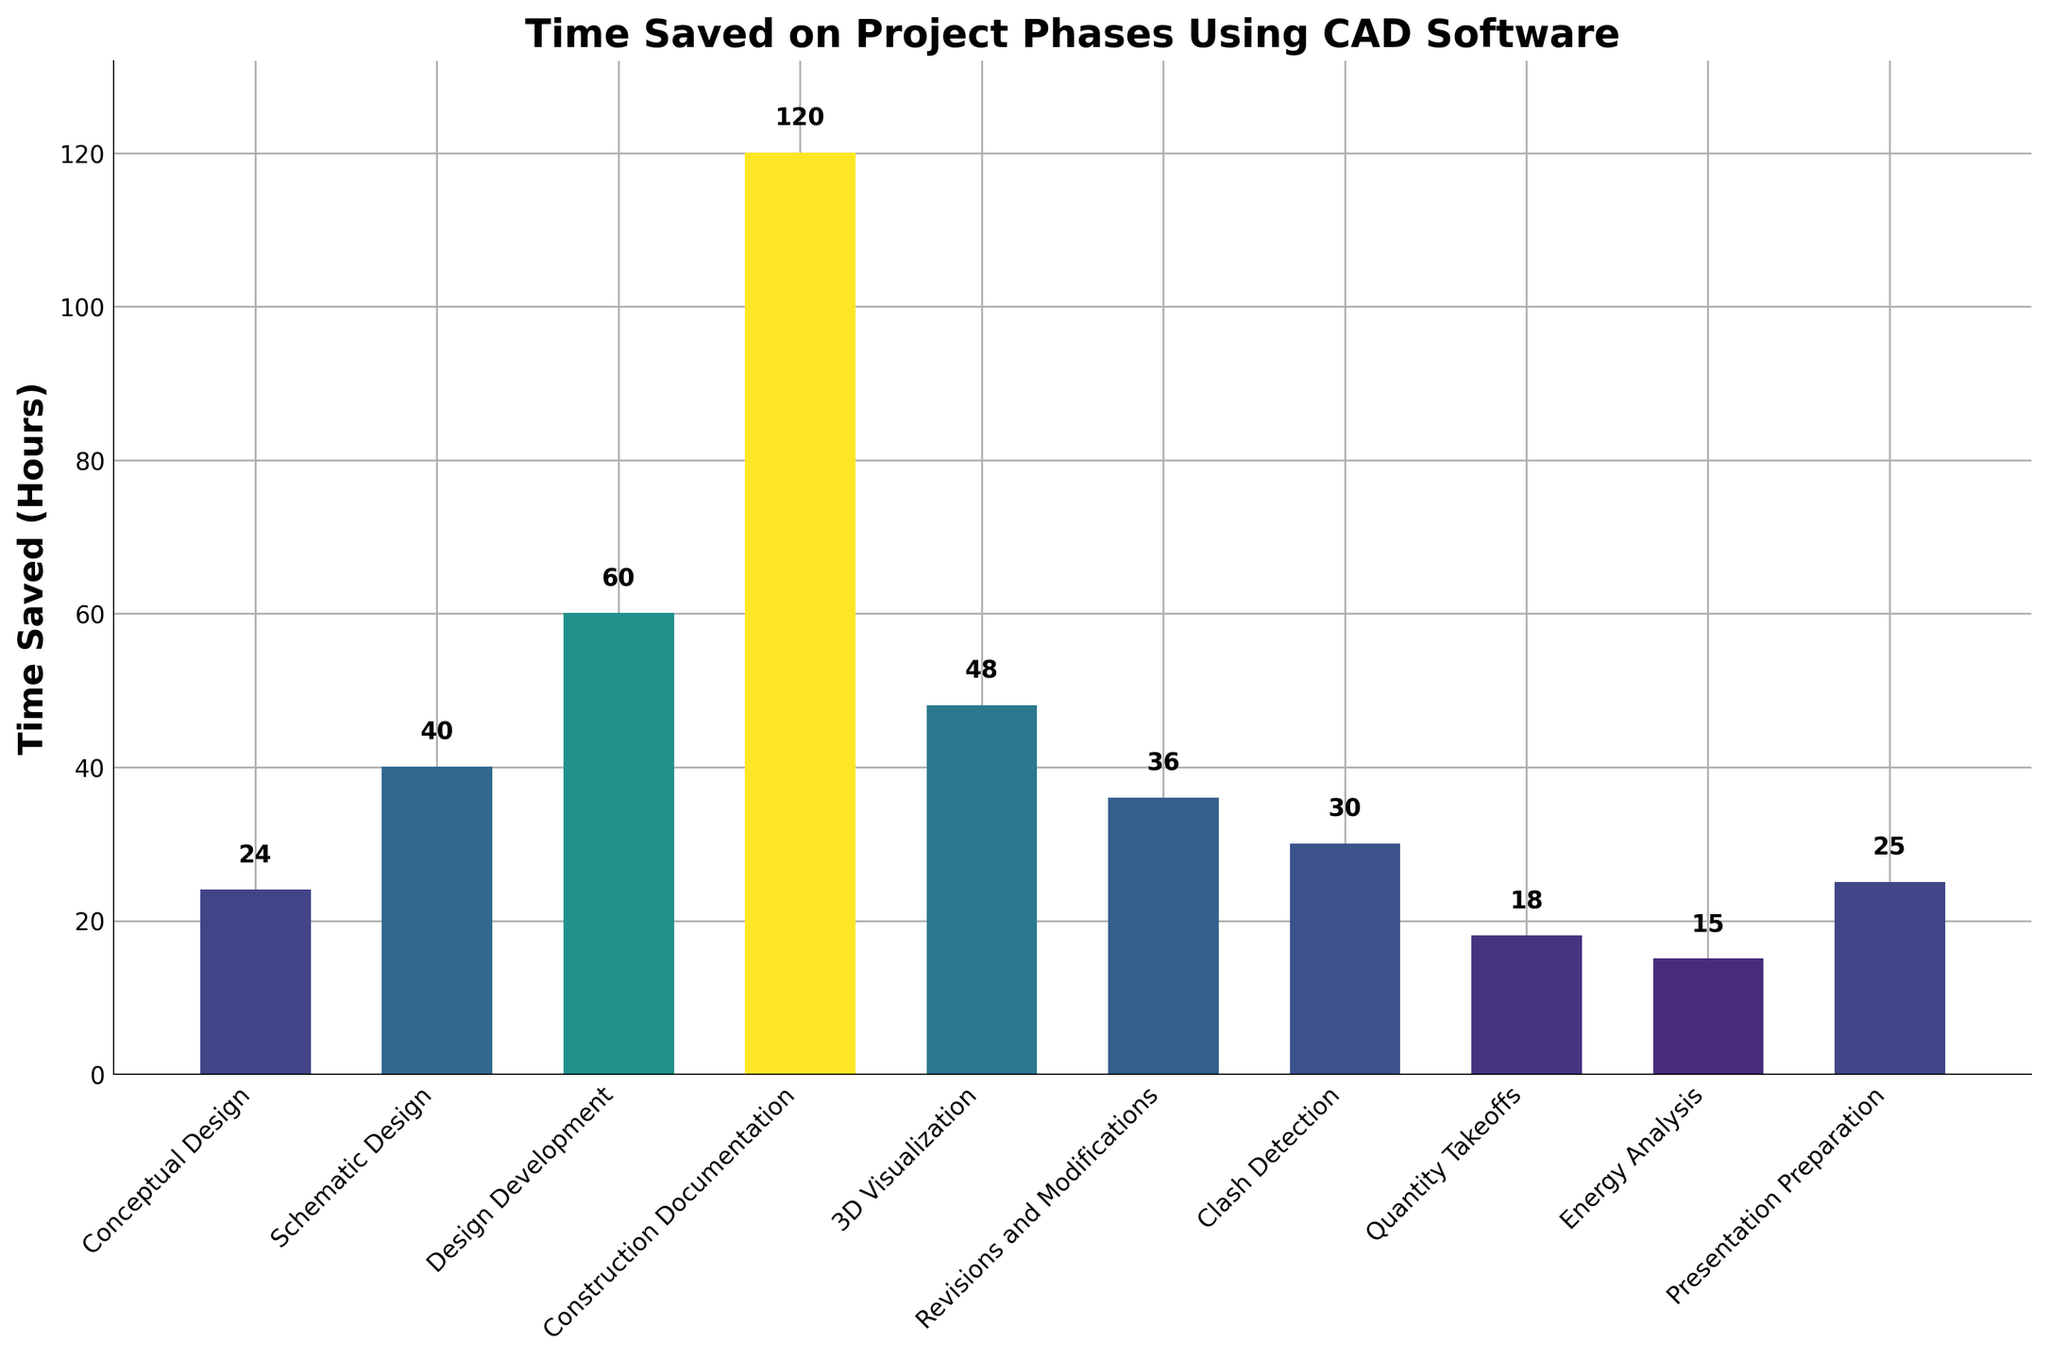Which project phase saves the most time using CAD software? By looking at the y-values of the bars, we can see which one is the tallest. The tallest bar corresponds to "Construction Documentation," which has a time saved of 120 hours.
Answer: Construction Documentation What is the total time saved across all project phases? Add up the time saved for each phase: 24 + 40 + 60 + 120 + 48 + 36 + 30 + 18 + 15 + 25 = 416 hours.
Answer: 416 hours How much more time is saved in Design Development compared to Clash Detection? The time saved in Design Development is 60 hours, and in Clash Detection, it is 30 hours. The difference is 60 - 30 = 30 hours.
Answer: 30 hours Which phase has the least time saved, and how much is it? By looking at the lowest bar, we find that "Energy Analysis" has the least time saved, which is 15 hours.
Answer: Energy Analysis, 15 hours What's the average time saved per project phase? Divide the total time saved by the number of project phases: 416 hours / 10 phases = 41.6 hours.
Answer: 41.6 hours What is the difference in time saved between the highest and lowest saving phases? The highest-saving phase is Construction Documentation (120 hours), and the lowest is Energy Analysis (15 hours). The difference is 120 - 15 = 105 hours.
Answer: 105 hours Rank the phases in terms of time saved, from highest to lowest. Listing the phases and their time saved values in descending order:
1. Construction Documentation: 120 hours
2. Design Development: 60 hours
3. 3D Visualization: 48 hours
4. Schematic Design: 40 hours
5. Revisions and Modifications: 36 hours
6. Conceptual Design: 24 hours
7. Presentation Preparation: 25 hours
8. Clash Detection: 30 hours
9. Quantity Takeoffs: 18 hours
10. Energy Analysis: 15 hours
Answer: 1. Construction Documentation, 2. Design Development, 3. 3D Visualization, 4. Schematic Design, 5. Revisions and Modifications, 6. Conceptual Design, 7. Presentation Preparation, 8. Clash Detection, 9. Quantity Takeoffs, 10. Energy Analysis Which phase has the most striking color, and why do you think so? The bar color follows a gradient based on the height (time saved). The "Construction Documentation" bar is the tallest and hence the most striking as it represents the greatest time saved and has the most vibrant color in the gradient.
Answer: Construction Documentation Is the time saved for Clash Detection greater than or equal to the time saved for Quantity Takeoffs plus Energy Analysis? Time saved for Clash Detection is 30 hours. Time saved for Quantity Takeoffs is 18 hours, and for Energy Analysis is 15 hours. Sum of Quantity Takeoffs and Energy Analysis is 18 + 15 = 33 hours. Since 30 is less than 33, the time saved for Clash Detection is not greater than or equal to the sum.
Answer: No 